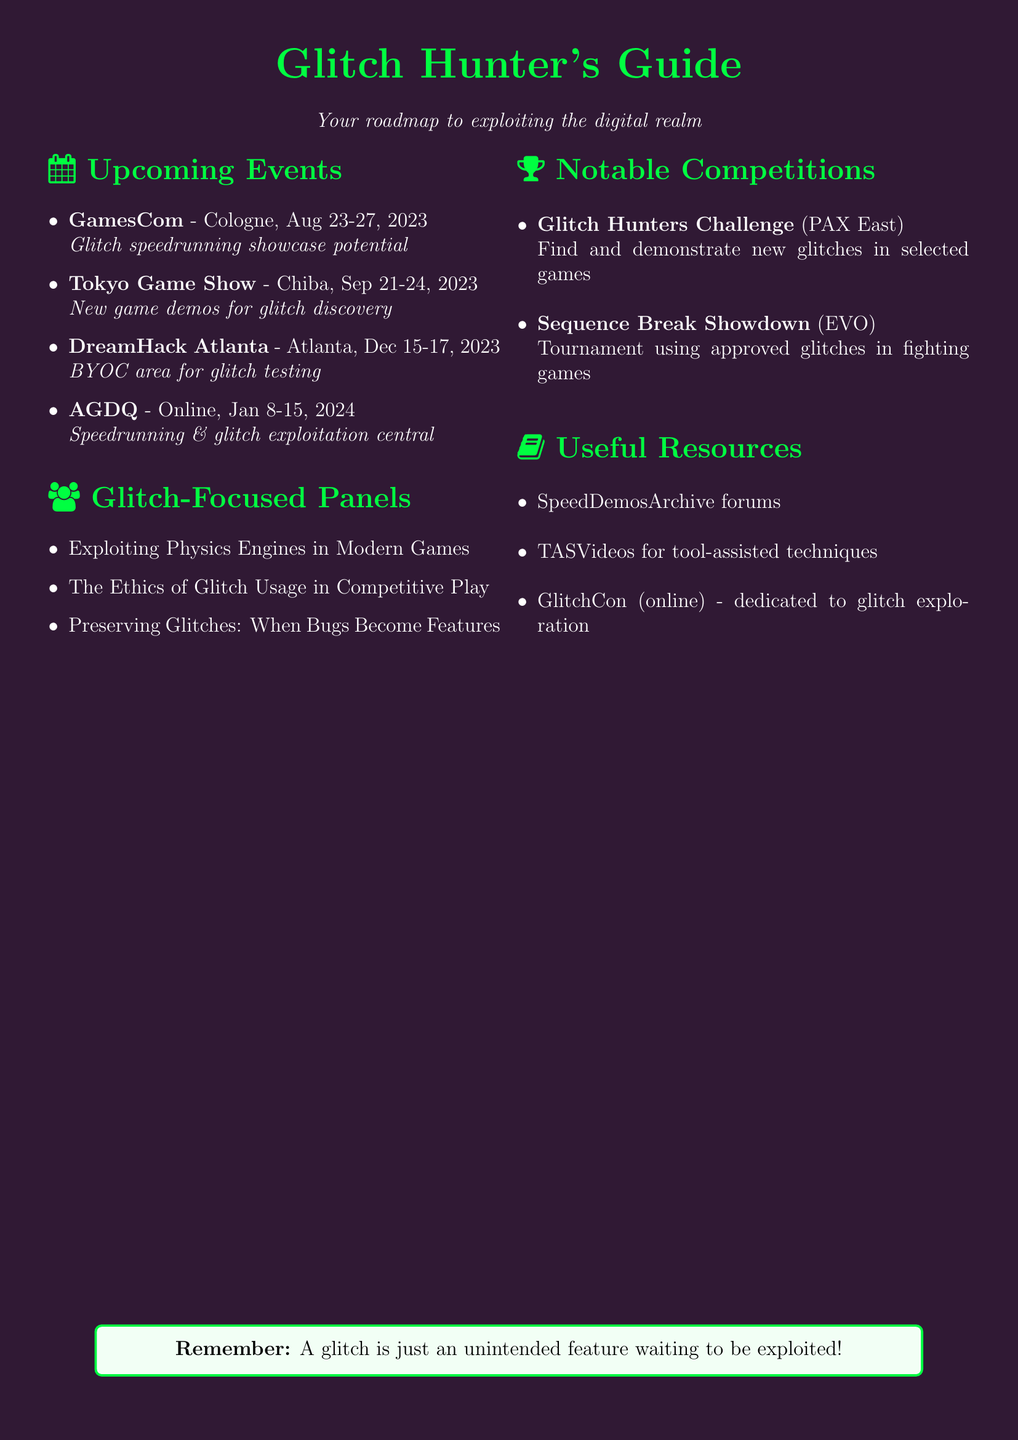What is the date for GamesCom? The date for GamesCom is specified in the document as August 23-27, 2023.
Answer: August 23-27, 2023 Where is the Tokyo Game Show located? The document indicates the location of the Tokyo Game Show as Chiba, Japan.
Answer: Chiba, Japan What type of event is Awesome Games Done Quick? The category of the event Awesome Games Done Quick is given in the notes as a speedrunning event, which is characterized by its focus on  exploiting glitches.
Answer: Speedrunning Which panel discusses the ethics of glitch usage? The document lists "The Ethics of Glitch Usage in Competitive Play" as one of the glitch-focused panels, which directly addresses that topic.
Answer: The Ethics of Glitch Usage in Competitive Play What is the name of the competition held at PAX East? The document mentions the "Glitch Hunters Challenge" as the competition occurring at PAX East.
Answer: Glitch Hunters Challenge How many days does DreamHack Atlanta last? The duration of DreamHack Atlanta, as specified in the date range in the document, is three days.
Answer: Three days Which event features a "Bring Your Own Computer" area? According to the notes, DreamHack Atlanta features a "Bring Your Own Computer" area, making it suitable for glitch testing.
Answer: DreamHack Atlanta What online event is dedicated to glitch exploration? The notes in the document highlight "GlitchCon" as the online event specifically dedicated to glitch exploration across all games.
Answer: GlitchCon 